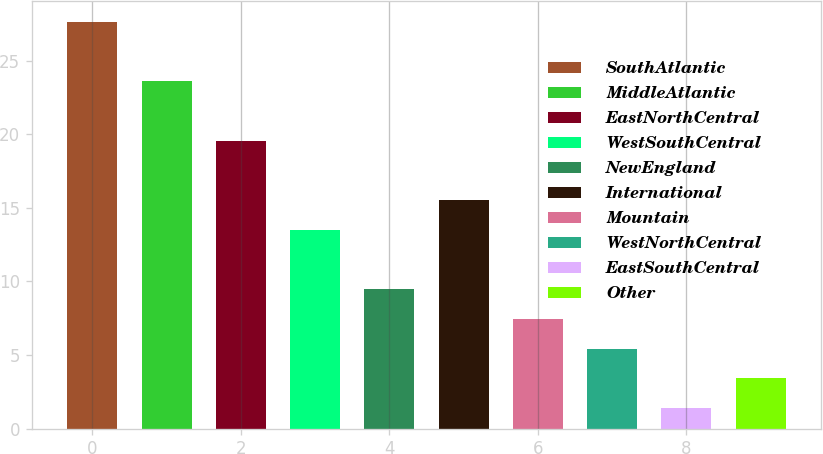Convert chart to OTSL. <chart><loc_0><loc_0><loc_500><loc_500><bar_chart><fcel>SouthAtlantic<fcel>MiddleAtlantic<fcel>EastNorthCentral<fcel>WestSouthCentral<fcel>NewEngland<fcel>International<fcel>Mountain<fcel>WestNorthCentral<fcel>EastSouthCentral<fcel>Other<nl><fcel>27.66<fcel>23.62<fcel>19.58<fcel>13.52<fcel>9.48<fcel>15.54<fcel>7.46<fcel>5.44<fcel>1.4<fcel>3.42<nl></chart> 